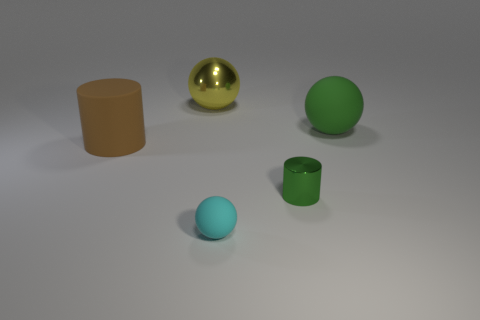What could be the purpose of these objects in a real-world setting? These objects could have various uses in the real world. The cyan sphere might be a small rubber ball used for decoration or play. The green cylindrical cup could be utilized for holding small items or as a simple container. The gold sphere seems decorative and could serve as an ornamental piece. The large brown cylinder might function as a storage bin or an open container for holding larger items. 